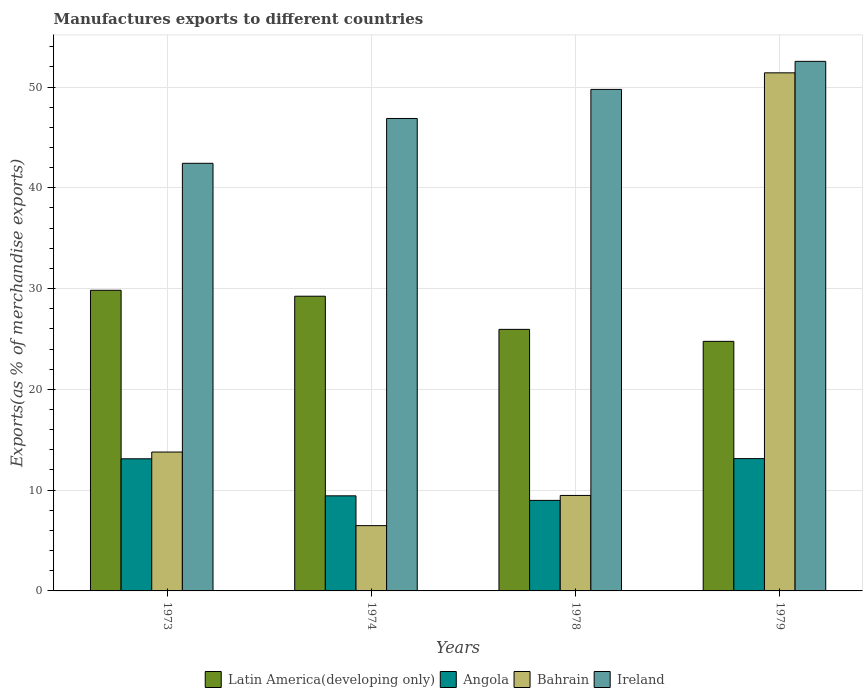How many bars are there on the 2nd tick from the right?
Provide a short and direct response. 4. What is the label of the 3rd group of bars from the left?
Provide a succinct answer. 1978. What is the percentage of exports to different countries in Angola in 1979?
Provide a short and direct response. 13.13. Across all years, what is the maximum percentage of exports to different countries in Bahrain?
Provide a short and direct response. 51.41. Across all years, what is the minimum percentage of exports to different countries in Angola?
Make the answer very short. 8.98. In which year was the percentage of exports to different countries in Angola maximum?
Keep it short and to the point. 1979. In which year was the percentage of exports to different countries in Angola minimum?
Keep it short and to the point. 1978. What is the total percentage of exports to different countries in Angola in the graph?
Offer a very short reply. 44.66. What is the difference between the percentage of exports to different countries in Ireland in 1973 and that in 1978?
Offer a very short reply. -7.33. What is the difference between the percentage of exports to different countries in Bahrain in 1974 and the percentage of exports to different countries in Ireland in 1979?
Offer a terse response. -46.07. What is the average percentage of exports to different countries in Angola per year?
Keep it short and to the point. 11.17. In the year 1979, what is the difference between the percentage of exports to different countries in Angola and percentage of exports to different countries in Latin America(developing only)?
Offer a terse response. -11.64. What is the ratio of the percentage of exports to different countries in Angola in 1974 to that in 1979?
Provide a short and direct response. 0.72. Is the percentage of exports to different countries in Ireland in 1974 less than that in 1979?
Keep it short and to the point. Yes. What is the difference between the highest and the second highest percentage of exports to different countries in Ireland?
Your answer should be very brief. 2.78. What is the difference between the highest and the lowest percentage of exports to different countries in Bahrain?
Your answer should be very brief. 44.93. In how many years, is the percentage of exports to different countries in Angola greater than the average percentage of exports to different countries in Angola taken over all years?
Your answer should be very brief. 2. What does the 3rd bar from the left in 1978 represents?
Make the answer very short. Bahrain. What does the 4th bar from the right in 1974 represents?
Offer a very short reply. Latin America(developing only). Is it the case that in every year, the sum of the percentage of exports to different countries in Bahrain and percentage of exports to different countries in Latin America(developing only) is greater than the percentage of exports to different countries in Angola?
Your answer should be compact. Yes. How many bars are there?
Your answer should be very brief. 16. Are all the bars in the graph horizontal?
Offer a terse response. No. Are the values on the major ticks of Y-axis written in scientific E-notation?
Ensure brevity in your answer.  No. Where does the legend appear in the graph?
Ensure brevity in your answer.  Bottom center. How many legend labels are there?
Offer a terse response. 4. How are the legend labels stacked?
Make the answer very short. Horizontal. What is the title of the graph?
Offer a terse response. Manufactures exports to different countries. Does "Botswana" appear as one of the legend labels in the graph?
Give a very brief answer. No. What is the label or title of the Y-axis?
Your answer should be compact. Exports(as % of merchandise exports). What is the Exports(as % of merchandise exports) of Latin America(developing only) in 1973?
Your response must be concise. 29.83. What is the Exports(as % of merchandise exports) in Angola in 1973?
Keep it short and to the point. 13.11. What is the Exports(as % of merchandise exports) of Bahrain in 1973?
Your response must be concise. 13.78. What is the Exports(as % of merchandise exports) of Ireland in 1973?
Your response must be concise. 42.43. What is the Exports(as % of merchandise exports) of Latin America(developing only) in 1974?
Provide a succinct answer. 29.24. What is the Exports(as % of merchandise exports) in Angola in 1974?
Offer a terse response. 9.44. What is the Exports(as % of merchandise exports) in Bahrain in 1974?
Offer a very short reply. 6.48. What is the Exports(as % of merchandise exports) of Ireland in 1974?
Give a very brief answer. 46.88. What is the Exports(as % of merchandise exports) in Latin America(developing only) in 1978?
Your response must be concise. 25.96. What is the Exports(as % of merchandise exports) of Angola in 1978?
Make the answer very short. 8.98. What is the Exports(as % of merchandise exports) in Bahrain in 1978?
Provide a succinct answer. 9.47. What is the Exports(as % of merchandise exports) in Ireland in 1978?
Provide a succinct answer. 49.77. What is the Exports(as % of merchandise exports) in Latin America(developing only) in 1979?
Keep it short and to the point. 24.77. What is the Exports(as % of merchandise exports) in Angola in 1979?
Your answer should be compact. 13.13. What is the Exports(as % of merchandise exports) in Bahrain in 1979?
Offer a terse response. 51.41. What is the Exports(as % of merchandise exports) in Ireland in 1979?
Make the answer very short. 52.55. Across all years, what is the maximum Exports(as % of merchandise exports) of Latin America(developing only)?
Provide a succinct answer. 29.83. Across all years, what is the maximum Exports(as % of merchandise exports) in Angola?
Give a very brief answer. 13.13. Across all years, what is the maximum Exports(as % of merchandise exports) in Bahrain?
Give a very brief answer. 51.41. Across all years, what is the maximum Exports(as % of merchandise exports) of Ireland?
Provide a succinct answer. 52.55. Across all years, what is the minimum Exports(as % of merchandise exports) in Latin America(developing only)?
Provide a succinct answer. 24.77. Across all years, what is the minimum Exports(as % of merchandise exports) in Angola?
Offer a terse response. 8.98. Across all years, what is the minimum Exports(as % of merchandise exports) of Bahrain?
Give a very brief answer. 6.48. Across all years, what is the minimum Exports(as % of merchandise exports) of Ireland?
Give a very brief answer. 42.43. What is the total Exports(as % of merchandise exports) in Latin America(developing only) in the graph?
Your answer should be compact. 109.8. What is the total Exports(as % of merchandise exports) of Angola in the graph?
Your answer should be very brief. 44.66. What is the total Exports(as % of merchandise exports) of Bahrain in the graph?
Offer a terse response. 81.15. What is the total Exports(as % of merchandise exports) in Ireland in the graph?
Give a very brief answer. 191.63. What is the difference between the Exports(as % of merchandise exports) in Latin America(developing only) in 1973 and that in 1974?
Your response must be concise. 0.59. What is the difference between the Exports(as % of merchandise exports) in Angola in 1973 and that in 1974?
Make the answer very short. 3.68. What is the difference between the Exports(as % of merchandise exports) in Bahrain in 1973 and that in 1974?
Offer a terse response. 7.3. What is the difference between the Exports(as % of merchandise exports) in Ireland in 1973 and that in 1974?
Provide a succinct answer. -4.45. What is the difference between the Exports(as % of merchandise exports) in Latin America(developing only) in 1973 and that in 1978?
Your response must be concise. 3.88. What is the difference between the Exports(as % of merchandise exports) of Angola in 1973 and that in 1978?
Your answer should be very brief. 4.13. What is the difference between the Exports(as % of merchandise exports) of Bahrain in 1973 and that in 1978?
Offer a terse response. 4.31. What is the difference between the Exports(as % of merchandise exports) in Ireland in 1973 and that in 1978?
Your response must be concise. -7.33. What is the difference between the Exports(as % of merchandise exports) in Latin America(developing only) in 1973 and that in 1979?
Your answer should be very brief. 5.07. What is the difference between the Exports(as % of merchandise exports) in Angola in 1973 and that in 1979?
Offer a very short reply. -0.02. What is the difference between the Exports(as % of merchandise exports) in Bahrain in 1973 and that in 1979?
Offer a terse response. -37.63. What is the difference between the Exports(as % of merchandise exports) of Ireland in 1973 and that in 1979?
Ensure brevity in your answer.  -10.12. What is the difference between the Exports(as % of merchandise exports) of Latin America(developing only) in 1974 and that in 1978?
Your response must be concise. 3.29. What is the difference between the Exports(as % of merchandise exports) of Angola in 1974 and that in 1978?
Keep it short and to the point. 0.45. What is the difference between the Exports(as % of merchandise exports) of Bahrain in 1974 and that in 1978?
Provide a succinct answer. -3. What is the difference between the Exports(as % of merchandise exports) of Ireland in 1974 and that in 1978?
Your answer should be compact. -2.89. What is the difference between the Exports(as % of merchandise exports) of Latin America(developing only) in 1974 and that in 1979?
Provide a succinct answer. 4.48. What is the difference between the Exports(as % of merchandise exports) in Angola in 1974 and that in 1979?
Ensure brevity in your answer.  -3.69. What is the difference between the Exports(as % of merchandise exports) in Bahrain in 1974 and that in 1979?
Give a very brief answer. -44.93. What is the difference between the Exports(as % of merchandise exports) in Ireland in 1974 and that in 1979?
Your answer should be very brief. -5.67. What is the difference between the Exports(as % of merchandise exports) of Latin America(developing only) in 1978 and that in 1979?
Offer a terse response. 1.19. What is the difference between the Exports(as % of merchandise exports) in Angola in 1978 and that in 1979?
Your answer should be very brief. -4.14. What is the difference between the Exports(as % of merchandise exports) in Bahrain in 1978 and that in 1979?
Keep it short and to the point. -41.94. What is the difference between the Exports(as % of merchandise exports) in Ireland in 1978 and that in 1979?
Your answer should be compact. -2.78. What is the difference between the Exports(as % of merchandise exports) of Latin America(developing only) in 1973 and the Exports(as % of merchandise exports) of Angola in 1974?
Your answer should be compact. 20.4. What is the difference between the Exports(as % of merchandise exports) of Latin America(developing only) in 1973 and the Exports(as % of merchandise exports) of Bahrain in 1974?
Your answer should be compact. 23.35. What is the difference between the Exports(as % of merchandise exports) in Latin America(developing only) in 1973 and the Exports(as % of merchandise exports) in Ireland in 1974?
Make the answer very short. -17.05. What is the difference between the Exports(as % of merchandise exports) of Angola in 1973 and the Exports(as % of merchandise exports) of Bahrain in 1974?
Provide a succinct answer. 6.63. What is the difference between the Exports(as % of merchandise exports) in Angola in 1973 and the Exports(as % of merchandise exports) in Ireland in 1974?
Make the answer very short. -33.77. What is the difference between the Exports(as % of merchandise exports) in Bahrain in 1973 and the Exports(as % of merchandise exports) in Ireland in 1974?
Offer a very short reply. -33.1. What is the difference between the Exports(as % of merchandise exports) in Latin America(developing only) in 1973 and the Exports(as % of merchandise exports) in Angola in 1978?
Keep it short and to the point. 20.85. What is the difference between the Exports(as % of merchandise exports) in Latin America(developing only) in 1973 and the Exports(as % of merchandise exports) in Bahrain in 1978?
Offer a terse response. 20.36. What is the difference between the Exports(as % of merchandise exports) in Latin America(developing only) in 1973 and the Exports(as % of merchandise exports) in Ireland in 1978?
Offer a very short reply. -19.94. What is the difference between the Exports(as % of merchandise exports) in Angola in 1973 and the Exports(as % of merchandise exports) in Bahrain in 1978?
Your answer should be compact. 3.64. What is the difference between the Exports(as % of merchandise exports) of Angola in 1973 and the Exports(as % of merchandise exports) of Ireland in 1978?
Give a very brief answer. -36.66. What is the difference between the Exports(as % of merchandise exports) in Bahrain in 1973 and the Exports(as % of merchandise exports) in Ireland in 1978?
Offer a terse response. -35.99. What is the difference between the Exports(as % of merchandise exports) of Latin America(developing only) in 1973 and the Exports(as % of merchandise exports) of Angola in 1979?
Offer a very short reply. 16.7. What is the difference between the Exports(as % of merchandise exports) in Latin America(developing only) in 1973 and the Exports(as % of merchandise exports) in Bahrain in 1979?
Provide a succinct answer. -21.58. What is the difference between the Exports(as % of merchandise exports) of Latin America(developing only) in 1973 and the Exports(as % of merchandise exports) of Ireland in 1979?
Ensure brevity in your answer.  -22.72. What is the difference between the Exports(as % of merchandise exports) in Angola in 1973 and the Exports(as % of merchandise exports) in Bahrain in 1979?
Your response must be concise. -38.3. What is the difference between the Exports(as % of merchandise exports) of Angola in 1973 and the Exports(as % of merchandise exports) of Ireland in 1979?
Keep it short and to the point. -39.44. What is the difference between the Exports(as % of merchandise exports) of Bahrain in 1973 and the Exports(as % of merchandise exports) of Ireland in 1979?
Offer a very short reply. -38.77. What is the difference between the Exports(as % of merchandise exports) in Latin America(developing only) in 1974 and the Exports(as % of merchandise exports) in Angola in 1978?
Offer a terse response. 20.26. What is the difference between the Exports(as % of merchandise exports) in Latin America(developing only) in 1974 and the Exports(as % of merchandise exports) in Bahrain in 1978?
Give a very brief answer. 19.77. What is the difference between the Exports(as % of merchandise exports) in Latin America(developing only) in 1974 and the Exports(as % of merchandise exports) in Ireland in 1978?
Your response must be concise. -20.52. What is the difference between the Exports(as % of merchandise exports) in Angola in 1974 and the Exports(as % of merchandise exports) in Bahrain in 1978?
Your answer should be very brief. -0.04. What is the difference between the Exports(as % of merchandise exports) in Angola in 1974 and the Exports(as % of merchandise exports) in Ireland in 1978?
Ensure brevity in your answer.  -40.33. What is the difference between the Exports(as % of merchandise exports) in Bahrain in 1974 and the Exports(as % of merchandise exports) in Ireland in 1978?
Your answer should be very brief. -43.29. What is the difference between the Exports(as % of merchandise exports) of Latin America(developing only) in 1974 and the Exports(as % of merchandise exports) of Angola in 1979?
Your response must be concise. 16.12. What is the difference between the Exports(as % of merchandise exports) of Latin America(developing only) in 1974 and the Exports(as % of merchandise exports) of Bahrain in 1979?
Ensure brevity in your answer.  -22.17. What is the difference between the Exports(as % of merchandise exports) of Latin America(developing only) in 1974 and the Exports(as % of merchandise exports) of Ireland in 1979?
Provide a short and direct response. -23.31. What is the difference between the Exports(as % of merchandise exports) of Angola in 1974 and the Exports(as % of merchandise exports) of Bahrain in 1979?
Give a very brief answer. -41.98. What is the difference between the Exports(as % of merchandise exports) in Angola in 1974 and the Exports(as % of merchandise exports) in Ireland in 1979?
Give a very brief answer. -43.11. What is the difference between the Exports(as % of merchandise exports) in Bahrain in 1974 and the Exports(as % of merchandise exports) in Ireland in 1979?
Provide a short and direct response. -46.07. What is the difference between the Exports(as % of merchandise exports) in Latin America(developing only) in 1978 and the Exports(as % of merchandise exports) in Angola in 1979?
Provide a succinct answer. 12.83. What is the difference between the Exports(as % of merchandise exports) in Latin America(developing only) in 1978 and the Exports(as % of merchandise exports) in Bahrain in 1979?
Make the answer very short. -25.46. What is the difference between the Exports(as % of merchandise exports) of Latin America(developing only) in 1978 and the Exports(as % of merchandise exports) of Ireland in 1979?
Your response must be concise. -26.6. What is the difference between the Exports(as % of merchandise exports) in Angola in 1978 and the Exports(as % of merchandise exports) in Bahrain in 1979?
Your answer should be very brief. -42.43. What is the difference between the Exports(as % of merchandise exports) of Angola in 1978 and the Exports(as % of merchandise exports) of Ireland in 1979?
Provide a short and direct response. -43.57. What is the difference between the Exports(as % of merchandise exports) of Bahrain in 1978 and the Exports(as % of merchandise exports) of Ireland in 1979?
Provide a short and direct response. -43.08. What is the average Exports(as % of merchandise exports) of Latin America(developing only) per year?
Your answer should be compact. 27.45. What is the average Exports(as % of merchandise exports) in Angola per year?
Give a very brief answer. 11.17. What is the average Exports(as % of merchandise exports) of Bahrain per year?
Provide a succinct answer. 20.29. What is the average Exports(as % of merchandise exports) of Ireland per year?
Your answer should be compact. 47.91. In the year 1973, what is the difference between the Exports(as % of merchandise exports) of Latin America(developing only) and Exports(as % of merchandise exports) of Angola?
Provide a short and direct response. 16.72. In the year 1973, what is the difference between the Exports(as % of merchandise exports) of Latin America(developing only) and Exports(as % of merchandise exports) of Bahrain?
Provide a succinct answer. 16.05. In the year 1973, what is the difference between the Exports(as % of merchandise exports) of Latin America(developing only) and Exports(as % of merchandise exports) of Ireland?
Give a very brief answer. -12.6. In the year 1973, what is the difference between the Exports(as % of merchandise exports) in Angola and Exports(as % of merchandise exports) in Bahrain?
Give a very brief answer. -0.67. In the year 1973, what is the difference between the Exports(as % of merchandise exports) of Angola and Exports(as % of merchandise exports) of Ireland?
Make the answer very short. -29.32. In the year 1973, what is the difference between the Exports(as % of merchandise exports) in Bahrain and Exports(as % of merchandise exports) in Ireland?
Your answer should be very brief. -28.65. In the year 1974, what is the difference between the Exports(as % of merchandise exports) of Latin America(developing only) and Exports(as % of merchandise exports) of Angola?
Your response must be concise. 19.81. In the year 1974, what is the difference between the Exports(as % of merchandise exports) of Latin America(developing only) and Exports(as % of merchandise exports) of Bahrain?
Keep it short and to the point. 22.77. In the year 1974, what is the difference between the Exports(as % of merchandise exports) of Latin America(developing only) and Exports(as % of merchandise exports) of Ireland?
Make the answer very short. -17.64. In the year 1974, what is the difference between the Exports(as % of merchandise exports) of Angola and Exports(as % of merchandise exports) of Bahrain?
Your answer should be very brief. 2.96. In the year 1974, what is the difference between the Exports(as % of merchandise exports) of Angola and Exports(as % of merchandise exports) of Ireland?
Give a very brief answer. -37.45. In the year 1974, what is the difference between the Exports(as % of merchandise exports) of Bahrain and Exports(as % of merchandise exports) of Ireland?
Offer a very short reply. -40.4. In the year 1978, what is the difference between the Exports(as % of merchandise exports) in Latin America(developing only) and Exports(as % of merchandise exports) in Angola?
Make the answer very short. 16.97. In the year 1978, what is the difference between the Exports(as % of merchandise exports) of Latin America(developing only) and Exports(as % of merchandise exports) of Bahrain?
Give a very brief answer. 16.48. In the year 1978, what is the difference between the Exports(as % of merchandise exports) of Latin America(developing only) and Exports(as % of merchandise exports) of Ireland?
Make the answer very short. -23.81. In the year 1978, what is the difference between the Exports(as % of merchandise exports) in Angola and Exports(as % of merchandise exports) in Bahrain?
Keep it short and to the point. -0.49. In the year 1978, what is the difference between the Exports(as % of merchandise exports) in Angola and Exports(as % of merchandise exports) in Ireland?
Make the answer very short. -40.78. In the year 1978, what is the difference between the Exports(as % of merchandise exports) in Bahrain and Exports(as % of merchandise exports) in Ireland?
Make the answer very short. -40.29. In the year 1979, what is the difference between the Exports(as % of merchandise exports) in Latin America(developing only) and Exports(as % of merchandise exports) in Angola?
Ensure brevity in your answer.  11.64. In the year 1979, what is the difference between the Exports(as % of merchandise exports) of Latin America(developing only) and Exports(as % of merchandise exports) of Bahrain?
Ensure brevity in your answer.  -26.65. In the year 1979, what is the difference between the Exports(as % of merchandise exports) in Latin America(developing only) and Exports(as % of merchandise exports) in Ireland?
Ensure brevity in your answer.  -27.78. In the year 1979, what is the difference between the Exports(as % of merchandise exports) of Angola and Exports(as % of merchandise exports) of Bahrain?
Give a very brief answer. -38.28. In the year 1979, what is the difference between the Exports(as % of merchandise exports) of Angola and Exports(as % of merchandise exports) of Ireland?
Your answer should be very brief. -39.42. In the year 1979, what is the difference between the Exports(as % of merchandise exports) of Bahrain and Exports(as % of merchandise exports) of Ireland?
Provide a short and direct response. -1.14. What is the ratio of the Exports(as % of merchandise exports) of Latin America(developing only) in 1973 to that in 1974?
Provide a short and direct response. 1.02. What is the ratio of the Exports(as % of merchandise exports) in Angola in 1973 to that in 1974?
Offer a terse response. 1.39. What is the ratio of the Exports(as % of merchandise exports) of Bahrain in 1973 to that in 1974?
Ensure brevity in your answer.  2.13. What is the ratio of the Exports(as % of merchandise exports) of Ireland in 1973 to that in 1974?
Offer a terse response. 0.91. What is the ratio of the Exports(as % of merchandise exports) of Latin America(developing only) in 1973 to that in 1978?
Ensure brevity in your answer.  1.15. What is the ratio of the Exports(as % of merchandise exports) of Angola in 1973 to that in 1978?
Ensure brevity in your answer.  1.46. What is the ratio of the Exports(as % of merchandise exports) in Bahrain in 1973 to that in 1978?
Offer a terse response. 1.45. What is the ratio of the Exports(as % of merchandise exports) of Ireland in 1973 to that in 1978?
Keep it short and to the point. 0.85. What is the ratio of the Exports(as % of merchandise exports) in Latin America(developing only) in 1973 to that in 1979?
Offer a very short reply. 1.2. What is the ratio of the Exports(as % of merchandise exports) in Angola in 1973 to that in 1979?
Provide a short and direct response. 1. What is the ratio of the Exports(as % of merchandise exports) in Bahrain in 1973 to that in 1979?
Your answer should be very brief. 0.27. What is the ratio of the Exports(as % of merchandise exports) of Ireland in 1973 to that in 1979?
Offer a terse response. 0.81. What is the ratio of the Exports(as % of merchandise exports) of Latin America(developing only) in 1974 to that in 1978?
Make the answer very short. 1.13. What is the ratio of the Exports(as % of merchandise exports) in Angola in 1974 to that in 1978?
Keep it short and to the point. 1.05. What is the ratio of the Exports(as % of merchandise exports) in Bahrain in 1974 to that in 1978?
Your answer should be compact. 0.68. What is the ratio of the Exports(as % of merchandise exports) of Ireland in 1974 to that in 1978?
Provide a succinct answer. 0.94. What is the ratio of the Exports(as % of merchandise exports) in Latin America(developing only) in 1974 to that in 1979?
Ensure brevity in your answer.  1.18. What is the ratio of the Exports(as % of merchandise exports) of Angola in 1974 to that in 1979?
Make the answer very short. 0.72. What is the ratio of the Exports(as % of merchandise exports) of Bahrain in 1974 to that in 1979?
Ensure brevity in your answer.  0.13. What is the ratio of the Exports(as % of merchandise exports) in Ireland in 1974 to that in 1979?
Offer a very short reply. 0.89. What is the ratio of the Exports(as % of merchandise exports) in Latin America(developing only) in 1978 to that in 1979?
Keep it short and to the point. 1.05. What is the ratio of the Exports(as % of merchandise exports) of Angola in 1978 to that in 1979?
Offer a terse response. 0.68. What is the ratio of the Exports(as % of merchandise exports) in Bahrain in 1978 to that in 1979?
Make the answer very short. 0.18. What is the ratio of the Exports(as % of merchandise exports) of Ireland in 1978 to that in 1979?
Offer a terse response. 0.95. What is the difference between the highest and the second highest Exports(as % of merchandise exports) in Latin America(developing only)?
Give a very brief answer. 0.59. What is the difference between the highest and the second highest Exports(as % of merchandise exports) in Angola?
Give a very brief answer. 0.02. What is the difference between the highest and the second highest Exports(as % of merchandise exports) of Bahrain?
Ensure brevity in your answer.  37.63. What is the difference between the highest and the second highest Exports(as % of merchandise exports) in Ireland?
Provide a short and direct response. 2.78. What is the difference between the highest and the lowest Exports(as % of merchandise exports) in Latin America(developing only)?
Offer a terse response. 5.07. What is the difference between the highest and the lowest Exports(as % of merchandise exports) in Angola?
Give a very brief answer. 4.14. What is the difference between the highest and the lowest Exports(as % of merchandise exports) of Bahrain?
Offer a very short reply. 44.93. What is the difference between the highest and the lowest Exports(as % of merchandise exports) of Ireland?
Offer a very short reply. 10.12. 